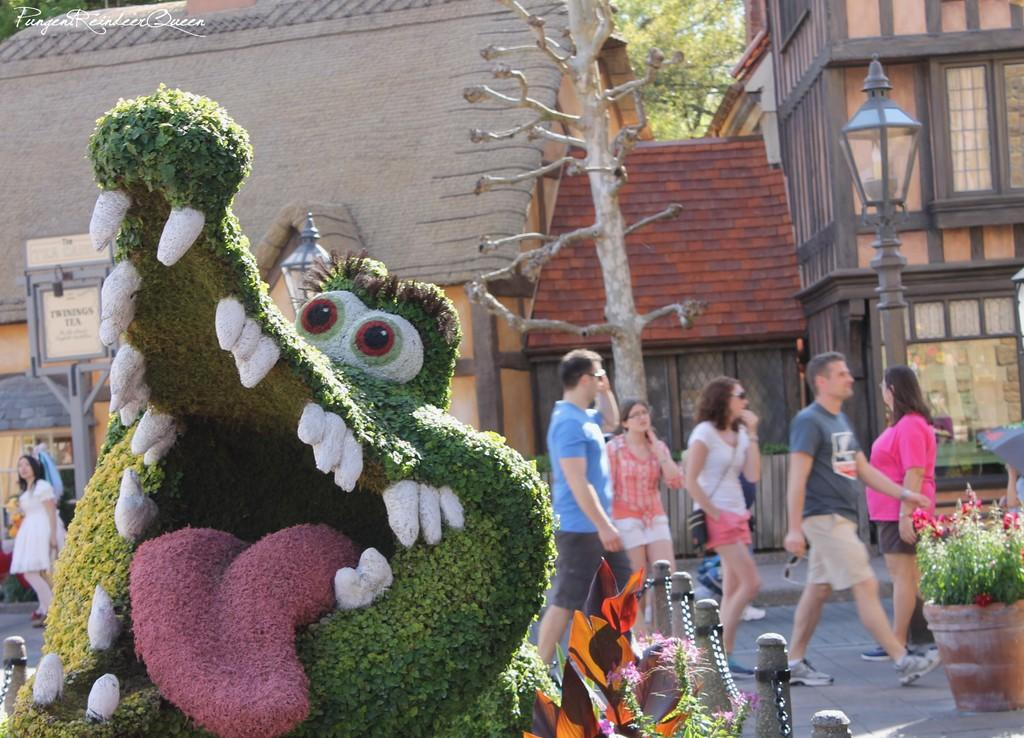What is the main subject in the image? There is a statue in the image. What can be seen in the background of the image? In the background, people are walking on a road, and there are trees and houses. What type of cherry is being served for breakfast in the image? There is no cherry or breakfast present in the image; it features a statue and people walking on a road in the background. 